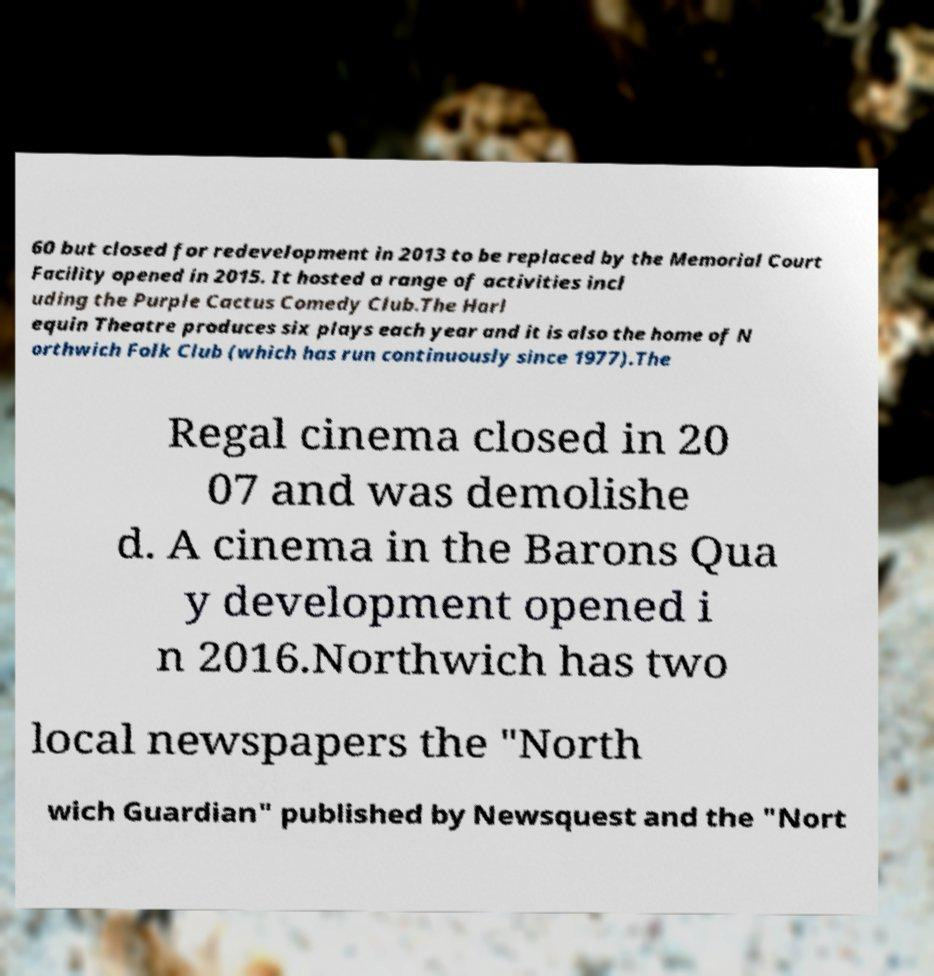Please read and relay the text visible in this image. What does it say? 60 but closed for redevelopment in 2013 to be replaced by the Memorial Court Facility opened in 2015. It hosted a range of activities incl uding the Purple Cactus Comedy Club.The Harl equin Theatre produces six plays each year and it is also the home of N orthwich Folk Club (which has run continuously since 1977).The Regal cinema closed in 20 07 and was demolishe d. A cinema in the Barons Qua y development opened i n 2016.Northwich has two local newspapers the "North wich Guardian" published by Newsquest and the "Nort 